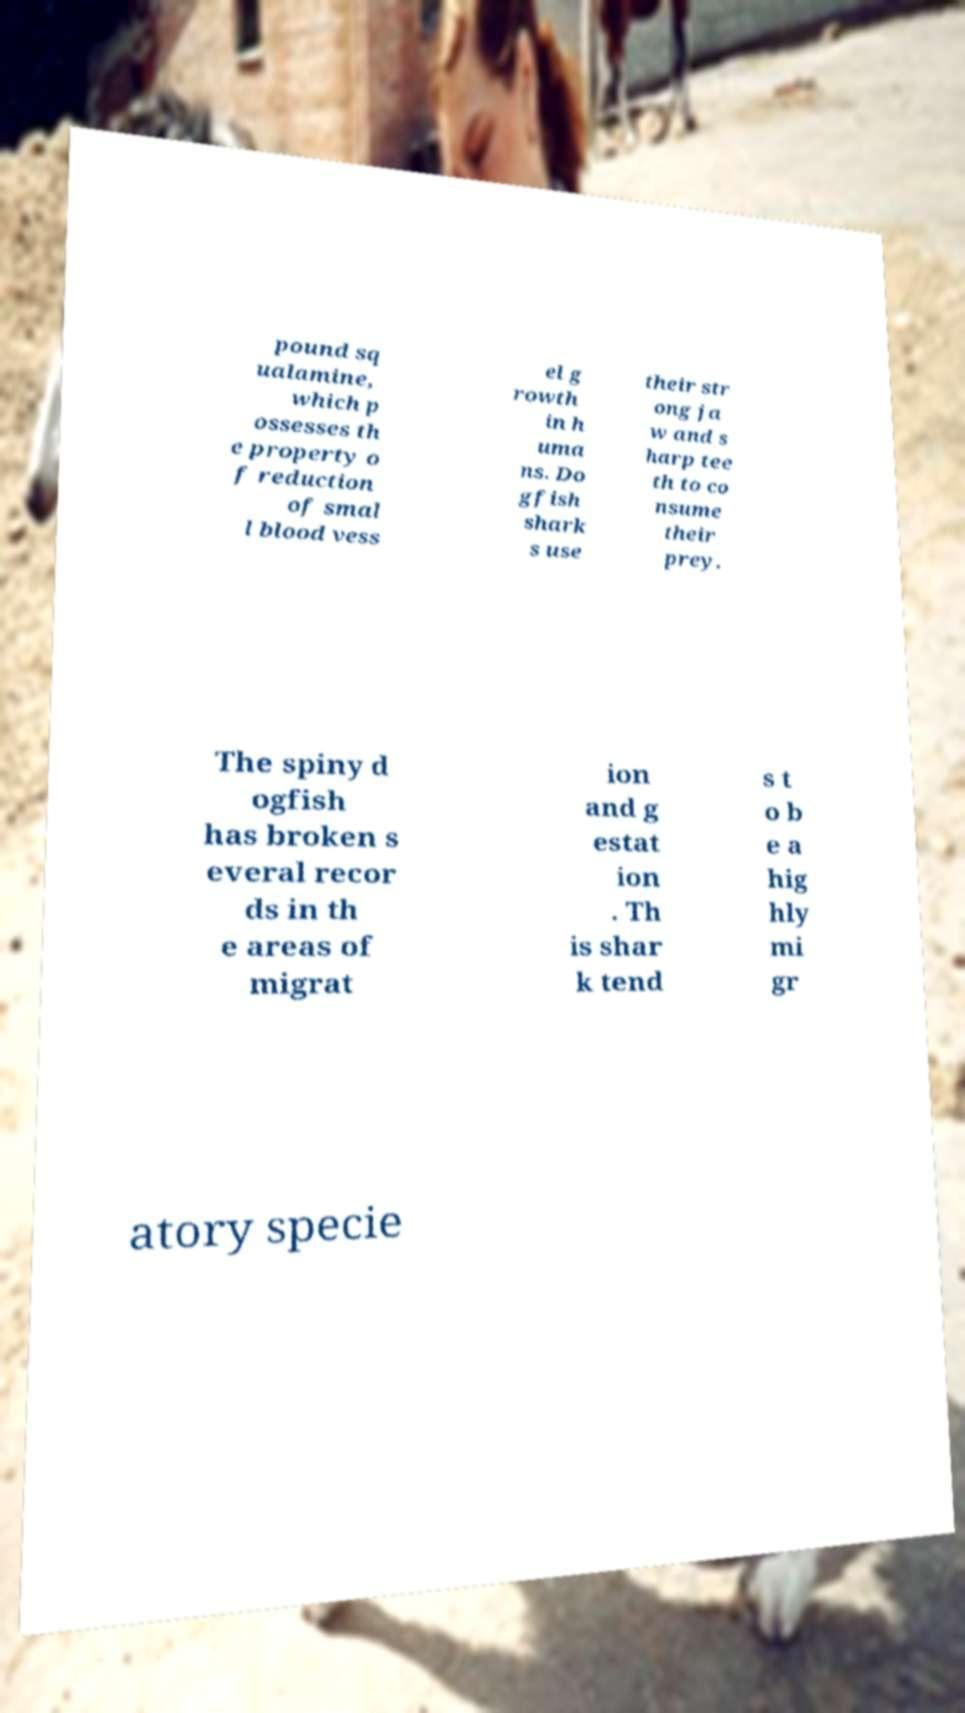Could you assist in decoding the text presented in this image and type it out clearly? pound sq ualamine, which p ossesses th e property o f reduction of smal l blood vess el g rowth in h uma ns. Do gfish shark s use their str ong ja w and s harp tee th to co nsume their prey. The spiny d ogfish has broken s everal recor ds in th e areas of migrat ion and g estat ion . Th is shar k tend s t o b e a hig hly mi gr atory specie 